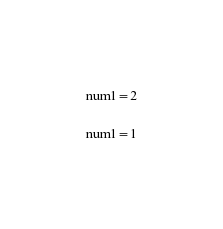<code> <loc_0><loc_0><loc_500><loc_500><_Python_>
num1=2

num1=1

</code> 